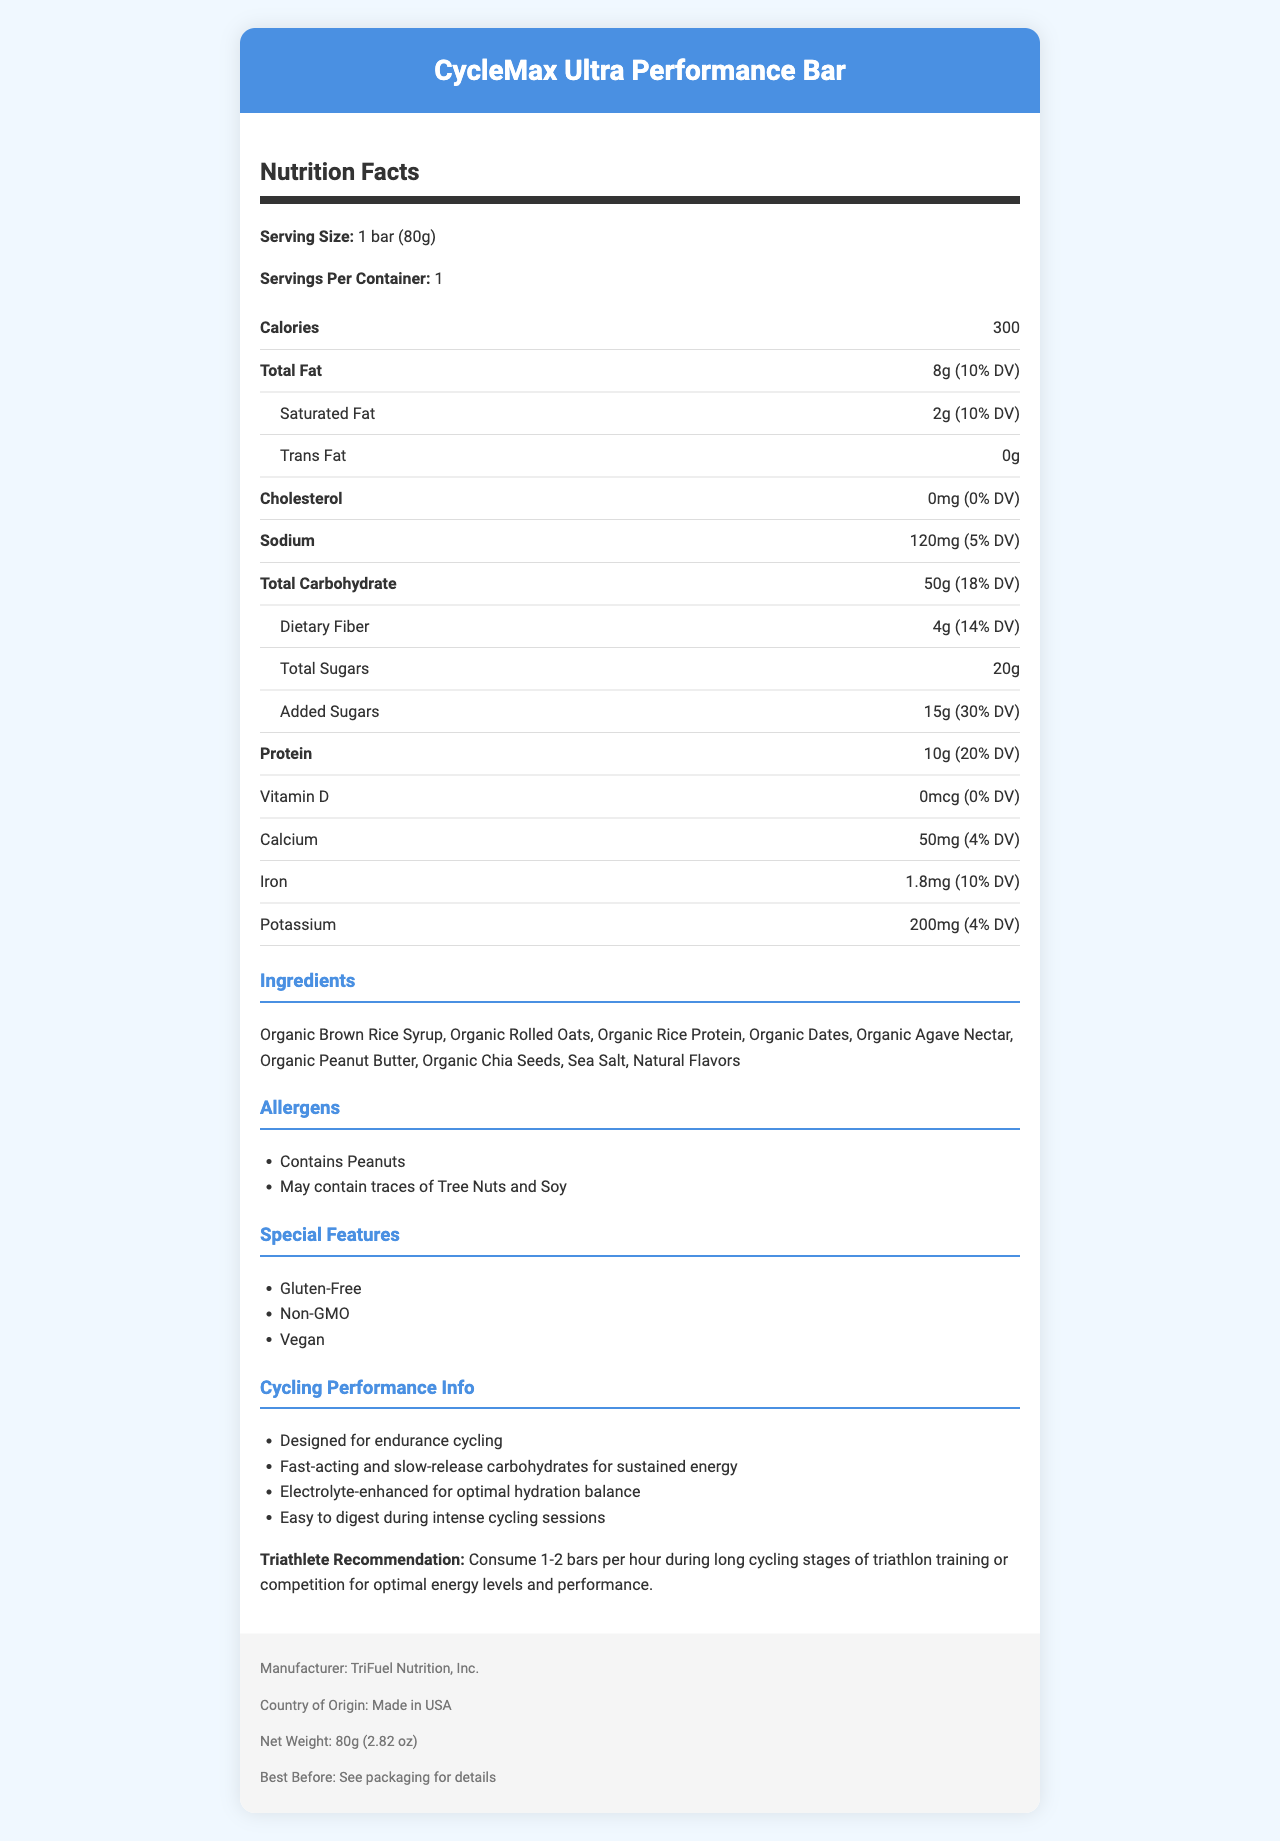what is the serving size? The serving size is specified in the Nutrition Facts section under "Serving Size".
Answer: 1 bar (80g) how many calories are in one serving of CycleMax Ultra Performance Bar? The number of calories per serving is listed directly under the Calories section.
Answer: 300 what percentage of Daily Value is the total carbohydrate content? The total carbohydrate content as a percentage of the Daily Value is provided as 18%.
Answer: 18% Is this product vegan? The document lists "Vegan" under the "Special Features" section.
Answer: Yes how much protein does one bar contain? The protein content per serving is provided under the Protein section.
Answer: 10g what is the amount of sodium in one bar? The sodium amount is specified under the Sodium section.
Answer: 120mg how much iron is in one serving? The amount of iron in one serving is listed under the Iron section.
Answer: 1.8mg What are some of the special features of this bar? A. Gluten-Free B. High in Protein C. Non-GMO D. Vegan The special features listed include "Gluten-Free", "Non-GMO", and "Vegan".
Answer: A, C, D What allergens does this product contain? A. Peanuts B. Tree Nuts C. Soy D. Dairy The product contains peanuts and may contain traces of tree nuts and soy.
Answer: A, B, C Is there any cholesterol in the CycleMax Ultra Performance Bar? The document states that the cholesterol amount is 0mg and percent daily value is 0.
Answer: No Does the CycleMax Ultra Performance Bar contain any trans fat? The document shows that the trans fat content is 0g.
Answer: No Summarize the main idea of this document. The document contains a detailed Nutrition Facts label along with additional sections on ingredients, allergens, special features, and cycling performance recommendations.
Answer: The document provides comprehensive nutritional information about the CycleMax Ultra Performance Bar, an energy bar optimized for cycling performance. It includes details on ingredients, allergens, special features (e.g., gluten-free, non-GMO, vegan), and specific recommendations for triathletes. how much added sugar is in the bar? The amount of added sugars per serving is specified in the Added Sugars section.
Answer: 15g What is the recommended consumption of this bar for triathletes during long cycling stages? The document includes a triathlete recommendation specifying the suggested consumption.
Answer: 1-2 bars per hour Who is the manufacturer of this energy bar? The manufacturer's information is provided at the end of the document.
Answer: TriFuel Nutrition, Inc. Is this product high in vitamin D? The document lists the vitamin D amount as 0mcg, which is 0% of the daily value.
Answer: No When should the CycleMax Ultra Performance Bar be consumed for optimal performance? While there is a recommendation for triathletes, the document does not provide specific timings for consumption outside of this context.
Answer: Cannot be determined 